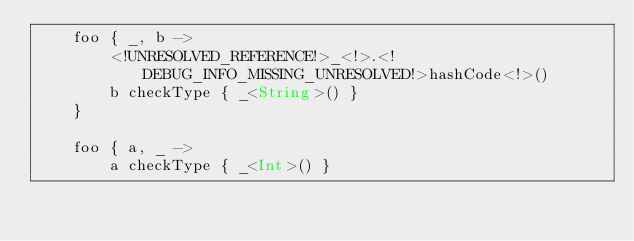<code> <loc_0><loc_0><loc_500><loc_500><_Kotlin_>    foo { _, b ->
        <!UNRESOLVED_REFERENCE!>_<!>.<!DEBUG_INFO_MISSING_UNRESOLVED!>hashCode<!>()
        b checkType { _<String>() }
    }

    foo { a, _ ->
        a checkType { _<Int>() }</code> 